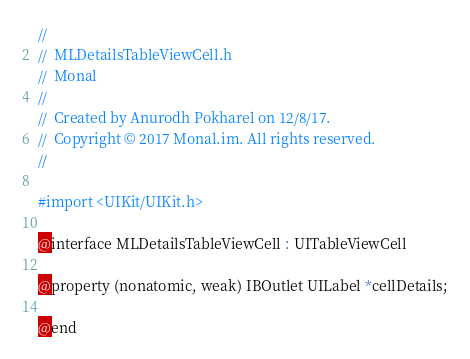Convert code to text. <code><loc_0><loc_0><loc_500><loc_500><_C_>//
//  MLDetailsTableViewCell.h
//  Monal
//
//  Created by Anurodh Pokharel on 12/8/17.
//  Copyright © 2017 Monal.im. All rights reserved.
//

#import <UIKit/UIKit.h>

@interface MLDetailsTableViewCell : UITableViewCell

@property (nonatomic, weak) IBOutlet UILabel *cellDetails;

@end
</code> 